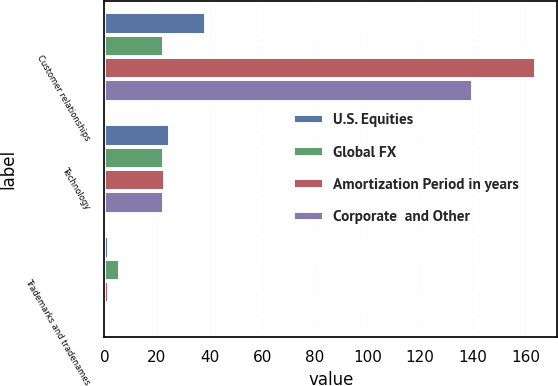Convert chart. <chart><loc_0><loc_0><loc_500><loc_500><stacked_bar_chart><ecel><fcel>Customer relationships<fcel>Technology<fcel>Trademarks and tradenames<nl><fcel>U.S. Equities<fcel>38.8<fcel>24.8<fcel>1.7<nl><fcel>Global FX<fcel>22.5<fcel>22.5<fcel>6<nl><fcel>Amortization Period in years<fcel>163.9<fcel>23.1<fcel>1.8<nl><fcel>Corporate  and Other<fcel>140<fcel>22.5<fcel>1.2<nl></chart> 